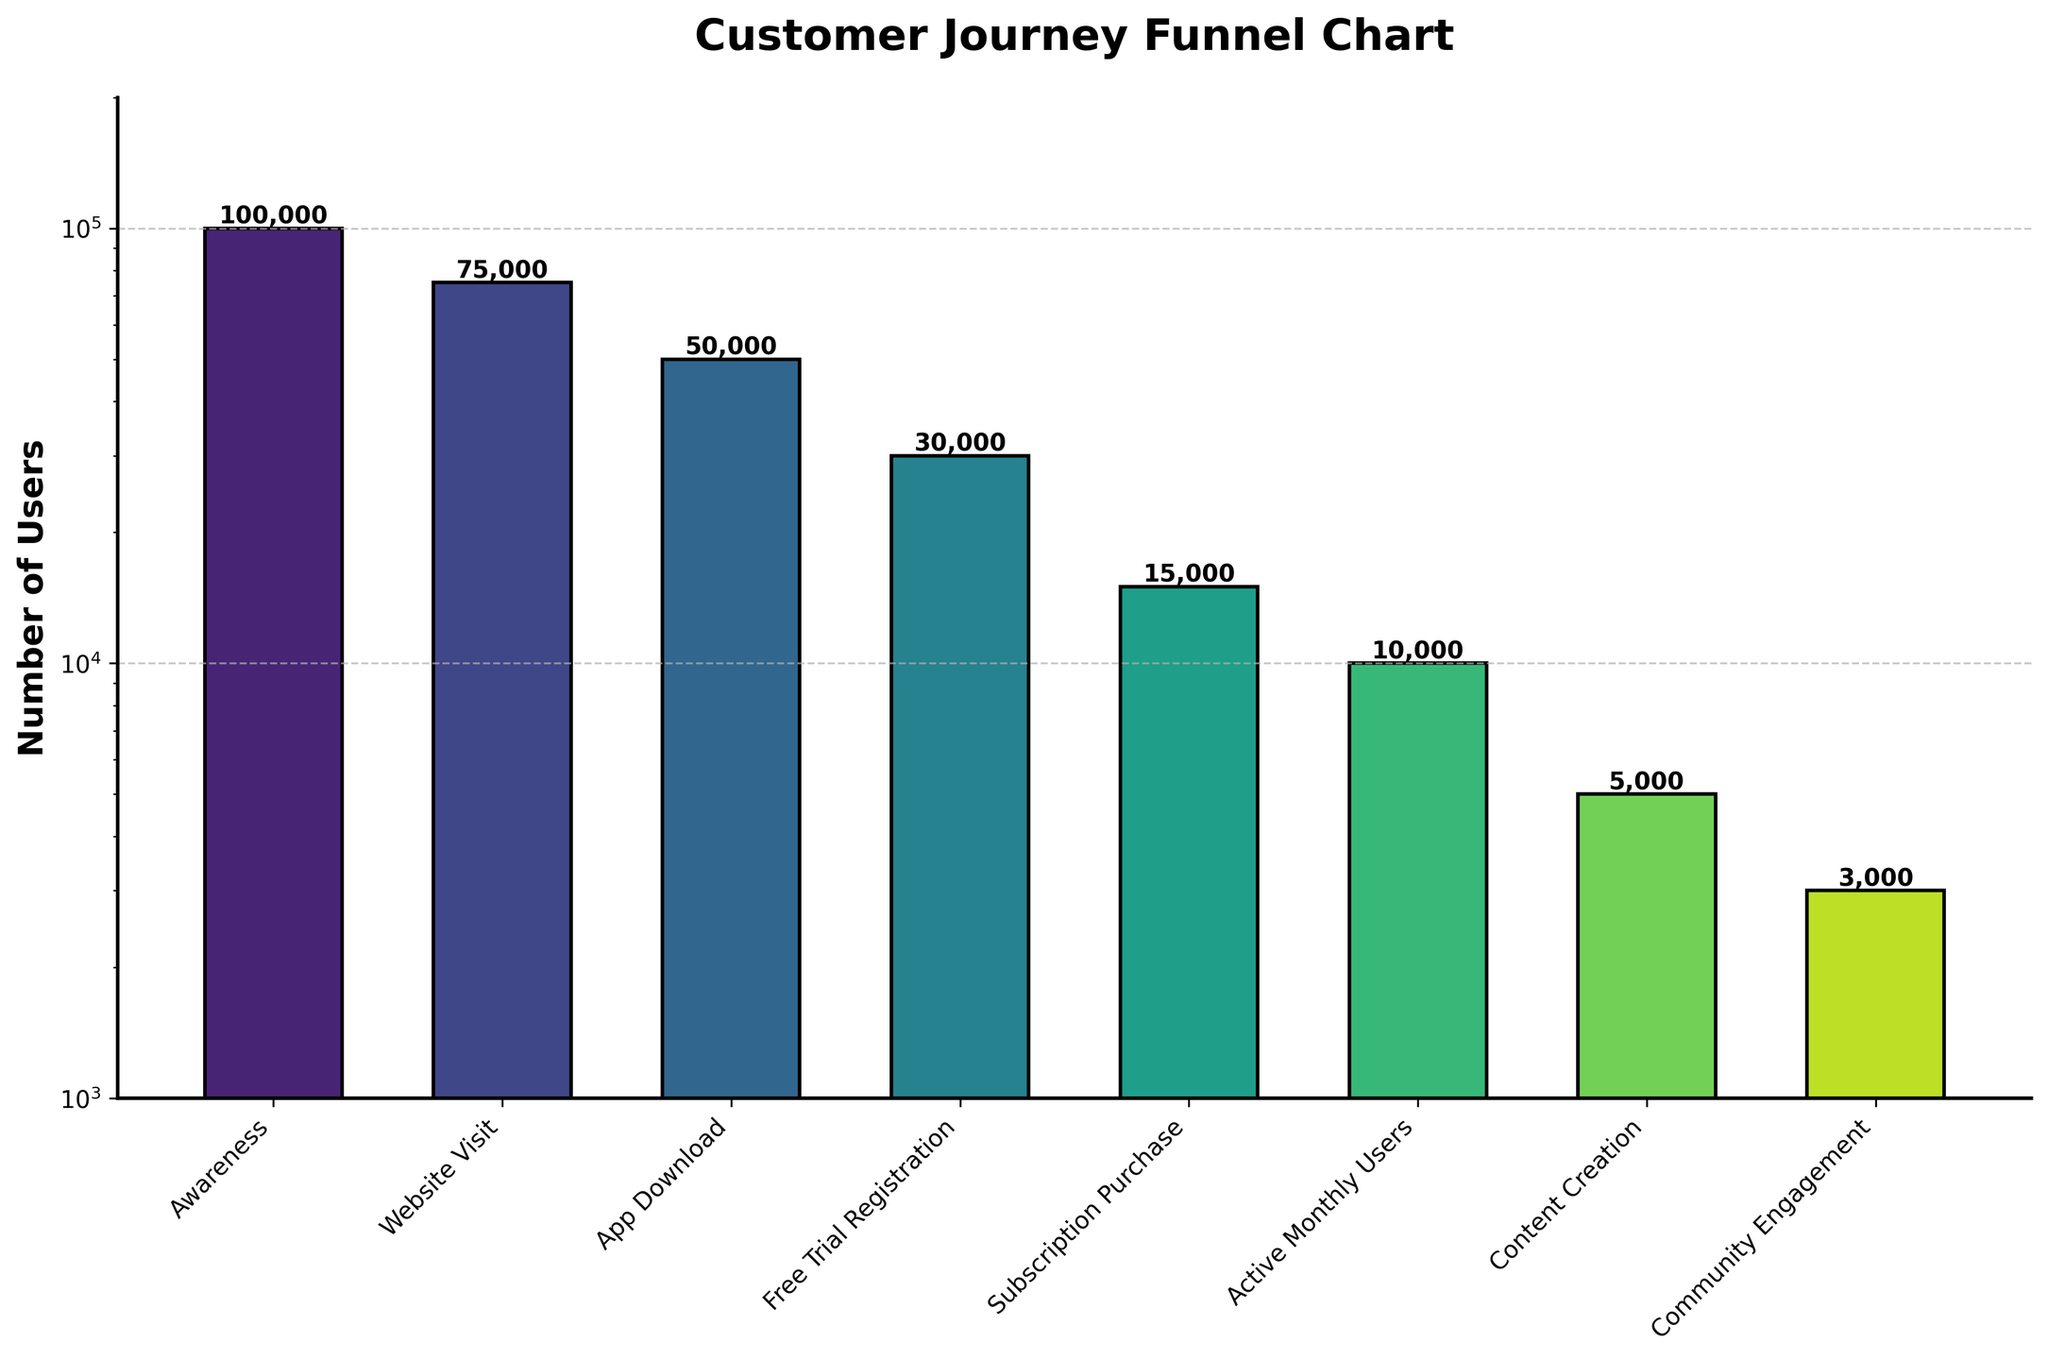What's the title of the funnel chart? The title is usually located at the top of the chart and visually identifies the theme or subject of the chart.
Answer: Customer Journey Funnel Chart What is the number of users at the "App Download" stage? Locate the bar representing the "App Download" stage, and read the value next to it.
Answer: 50,000 Which stage has the lowest number of users? Compare the heights of all bars and identify the shortest one, which represents the fewest users.
Answer: Community Engagement How many users are lost between the "Free Trial Registration" stage and the "Subscription Purchase" stage? Subtract the number of users at "Subscription Purchase" from the number of users at "Free Trial Registration" (30,000 - 15,000).
Answer: 15,000 What is the approximate decrease in users from the "Awareness" stage to "Website Visit" stage in terms of percentage? Calculate the difference in users between the stages, then divide by the number of users at the "Awareness" stage and multiply by 100 ((100,000 - 75,000) / 100,000 * 100).
Answer: 25% Which stages exhibit user numbers in the range of 1,000 to 20,000? Identify the stages where the y-axis values fall between 1,000 and 20,000.
Answer: Subscription Purchase, Active Monthly Users, Content Creation, Community Engagement How many stages are there in the customer journey? Count the total number of distinct stages along the x-axis.
Answer: 8 What proportion of users who visit the website end up registering for a free trial? Divide the number of users at the "Free Trial Registration" stage by the number of users at the "Website Visit" stage and multiply by 100 (30,000 / 75,000 * 100).
Answer: 40% What is the ratio of users at the "Active Monthly Users" stage compared to the "App Download" stage? Divide the number of users at "Active Monthly Users" by the number of users at "App Download" (10,000 / 50,000).
Answer: 0.2 By how much does the number of users drop from the "App Download" stage to the "Content Creation" stage? Subtract the number of users at "Content Creation" from the number of users at "App Download" (50,000 - 5,000).
Answer: 45,000 